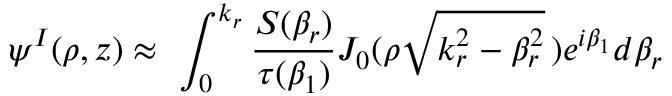<formula> <loc_0><loc_0><loc_500><loc_500>\psi ^ { I } ( \rho , z ) \approx \ \int _ { 0 } ^ { k _ { r } } \frac { S ( \beta _ { r } ) } { \tau ( \beta _ { 1 } ) } J _ { 0 } ( \rho \sqrt { k _ { r } ^ { 2 } - \beta _ { r } ^ { 2 } } \, ) e ^ { i \beta _ { 1 } } d \beta _ { r }</formula> 